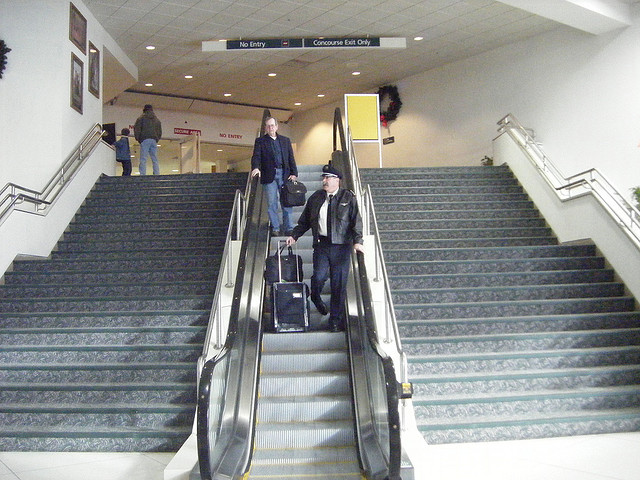Identify the text contained in this image. Cornourse No 